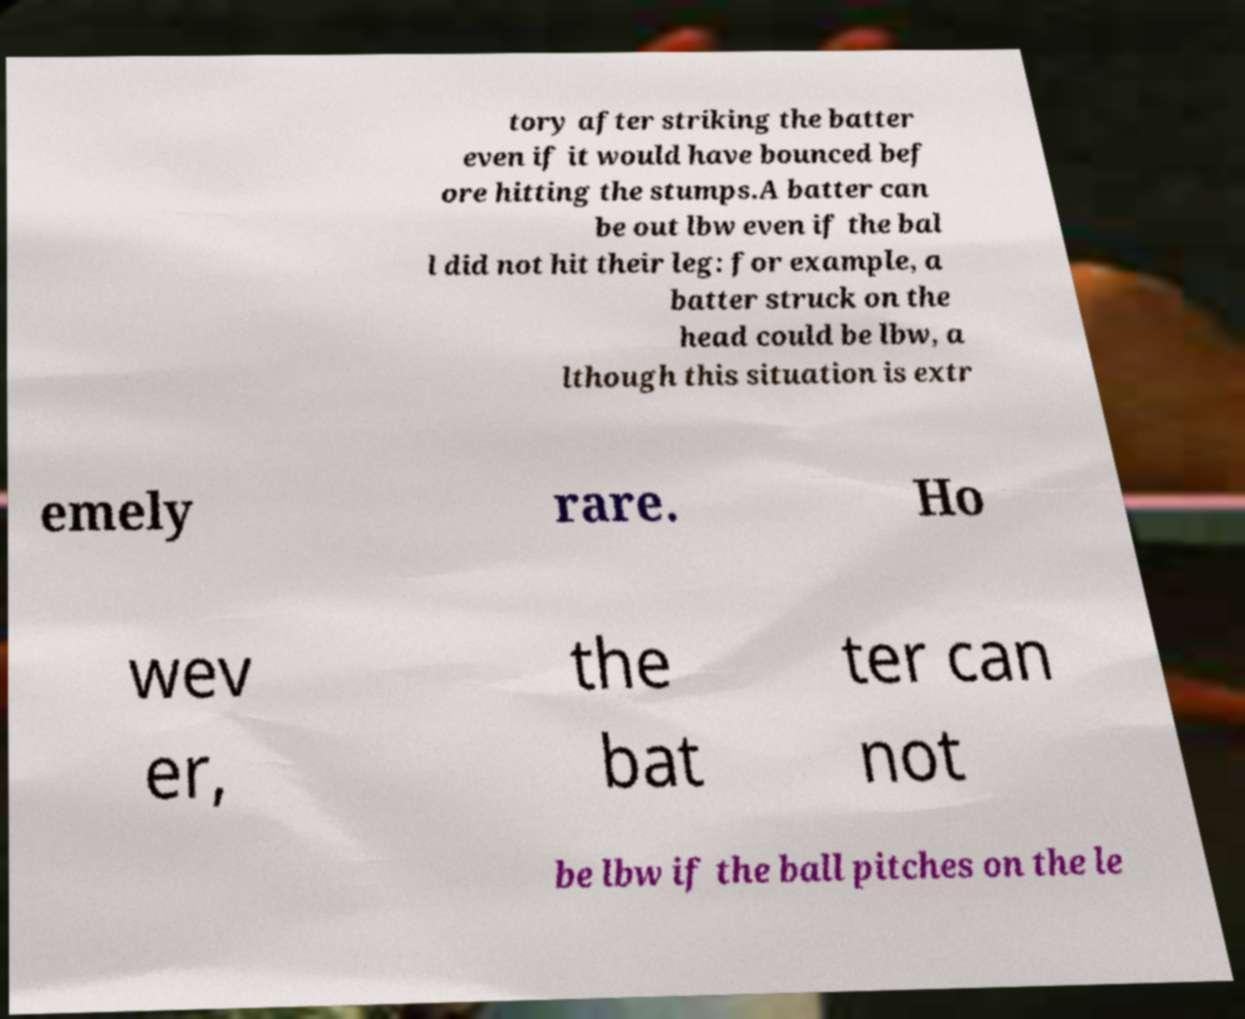Could you assist in decoding the text presented in this image and type it out clearly? tory after striking the batter even if it would have bounced bef ore hitting the stumps.A batter can be out lbw even if the bal l did not hit their leg: for example, a batter struck on the head could be lbw, a lthough this situation is extr emely rare. Ho wev er, the bat ter can not be lbw if the ball pitches on the le 